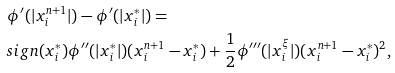Convert formula to latex. <formula><loc_0><loc_0><loc_500><loc_500>& \phi ^ { \prime } ( | x _ { i } ^ { n + 1 } | ) - \phi ^ { \prime } ( | x _ { i } ^ { * } | ) = \\ & s i g n ( x _ { i } ^ { * } ) \phi ^ { \prime \prime } ( | x _ { i } ^ { * } | ) ( x _ { i } ^ { n + 1 } - x _ { i } ^ { * } ) + \frac { 1 } { 2 } \phi ^ { \prime \prime \prime } ( | x _ { i } ^ { \xi } | ) ( x _ { i } ^ { n + 1 } - x _ { i } ^ { * } ) ^ { 2 } ,</formula> 